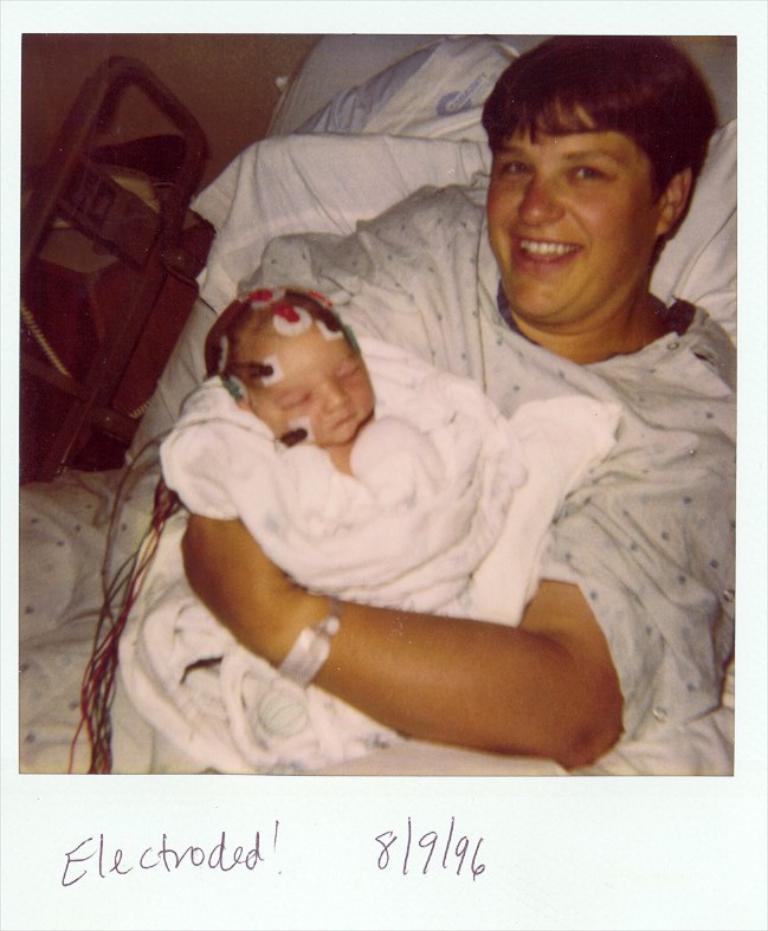Please provide a concise description of this image. In the center of the image, we can see a person smiling and lying on the bed and holding a baby. In the background, there are some other objects and at the bottom, we can see some text written. 